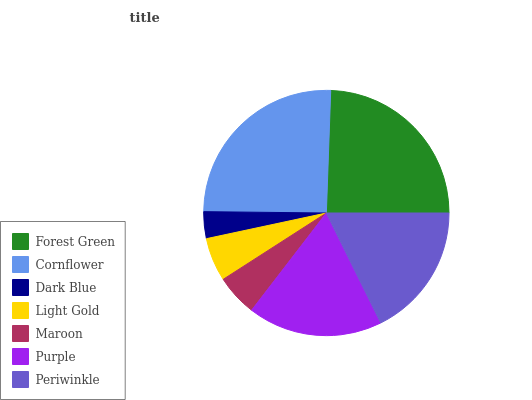Is Dark Blue the minimum?
Answer yes or no. Yes. Is Cornflower the maximum?
Answer yes or no. Yes. Is Cornflower the minimum?
Answer yes or no. No. Is Dark Blue the maximum?
Answer yes or no. No. Is Cornflower greater than Dark Blue?
Answer yes or no. Yes. Is Dark Blue less than Cornflower?
Answer yes or no. Yes. Is Dark Blue greater than Cornflower?
Answer yes or no. No. Is Cornflower less than Dark Blue?
Answer yes or no. No. Is Periwinkle the high median?
Answer yes or no. Yes. Is Periwinkle the low median?
Answer yes or no. Yes. Is Forest Green the high median?
Answer yes or no. No. Is Light Gold the low median?
Answer yes or no. No. 